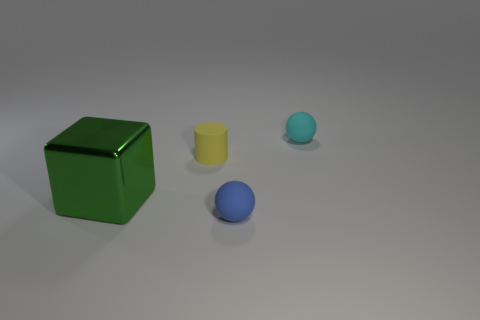What size is the thing on the left side of the small yellow rubber thing?
Keep it short and to the point. Large. There is a matte thing in front of the green thing; does it have the same size as the cyan object that is behind the tiny yellow cylinder?
Provide a short and direct response. Yes. How many tiny purple things are made of the same material as the blue object?
Your response must be concise. 0. What color is the metal block?
Make the answer very short. Green. There is a big cube; are there any spheres behind it?
Your response must be concise. Yes. How many other big metal blocks have the same color as the big metallic cube?
Provide a short and direct response. 0. There is a green cube that is behind the tiny sphere that is in front of the cyan object; how big is it?
Offer a terse response. Large. There is a cyan object; what shape is it?
Make the answer very short. Sphere. What is the material of the object behind the small yellow rubber thing?
Give a very brief answer. Rubber. The thing that is to the right of the tiny rubber sphere that is on the left side of the ball that is behind the blue rubber thing is what color?
Your answer should be compact. Cyan. 